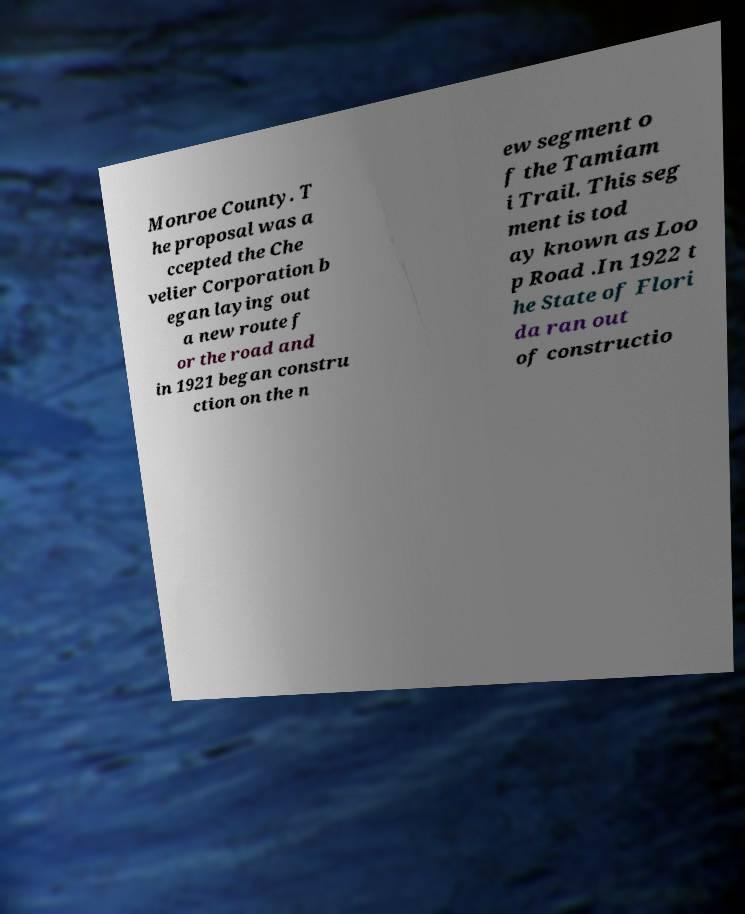Could you assist in decoding the text presented in this image and type it out clearly? Monroe County. T he proposal was a ccepted the Che velier Corporation b egan laying out a new route f or the road and in 1921 began constru ction on the n ew segment o f the Tamiam i Trail. This seg ment is tod ay known as Loo p Road .In 1922 t he State of Flori da ran out of constructio 